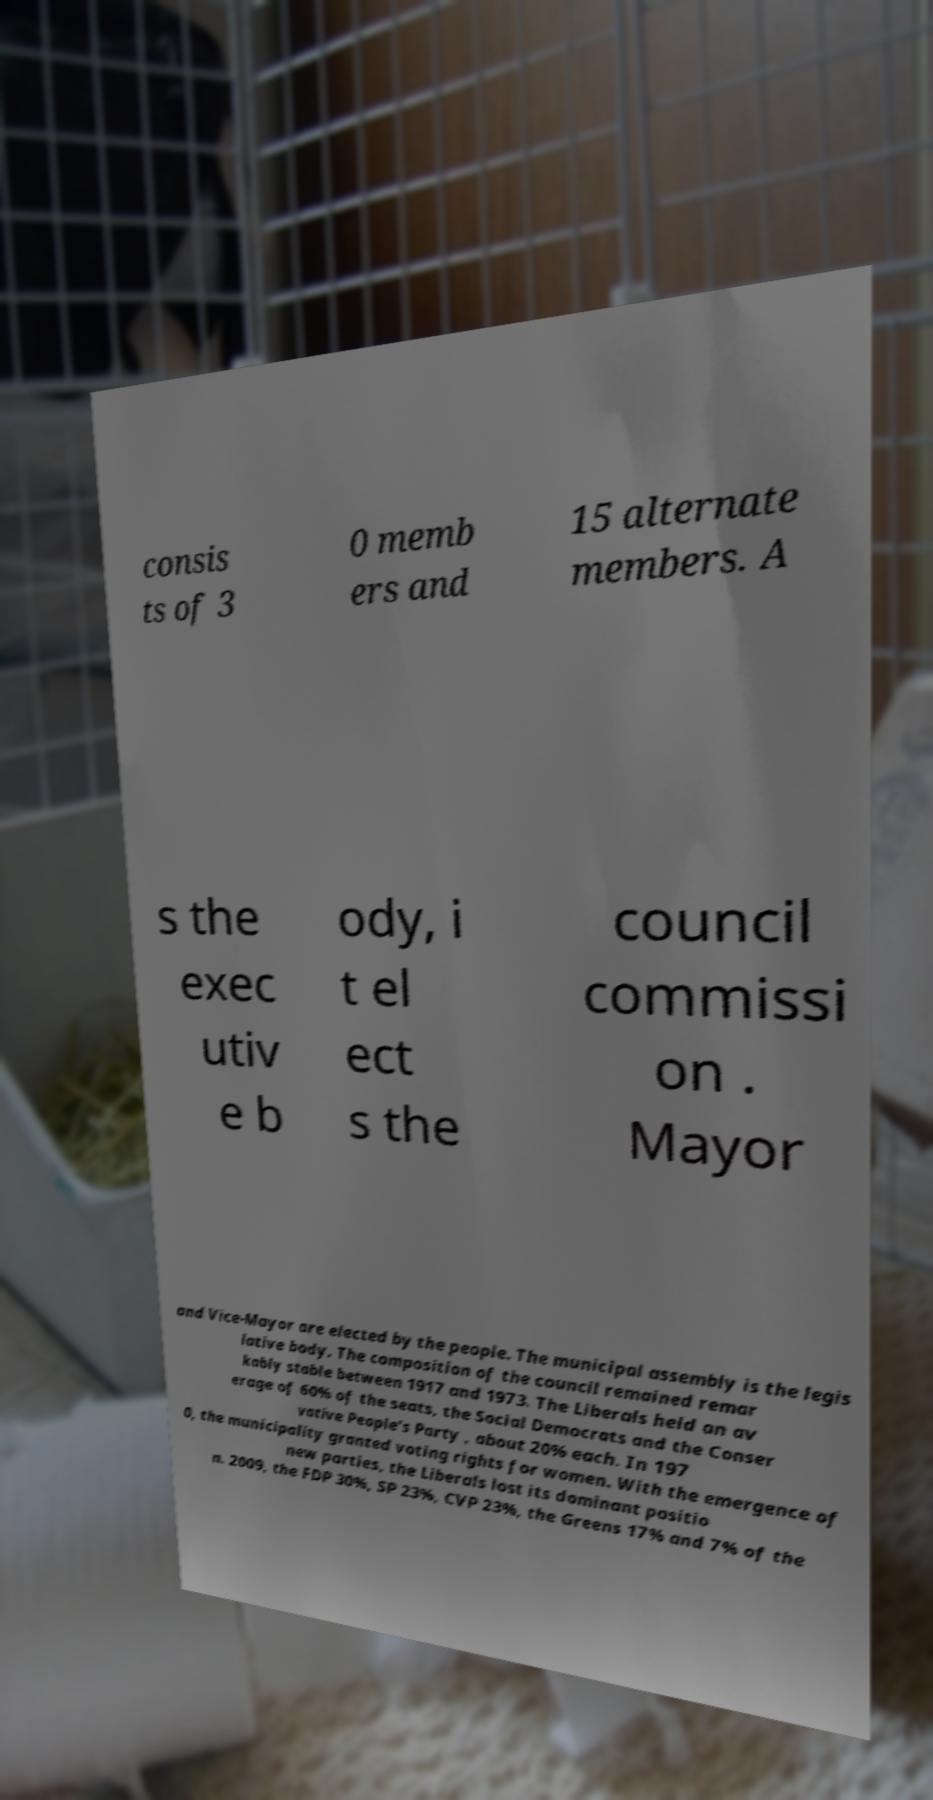Could you assist in decoding the text presented in this image and type it out clearly? consis ts of 3 0 memb ers and 15 alternate members. A s the exec utiv e b ody, i t el ect s the council commissi on . Mayor and Vice-Mayor are elected by the people. The municipal assembly is the legis lative body. The composition of the council remained remar kably stable between 1917 and 1973. The Liberals held an av erage of 60% of the seats, the Social Democrats and the Conser vative People's Party , about 20% each. In 197 0, the municipality granted voting rights for women. With the emergence of new parties, the Liberals lost its dominant positio n. 2009, the FDP 30%, SP 23%, CVP 23%, the Greens 17% and 7% of the 